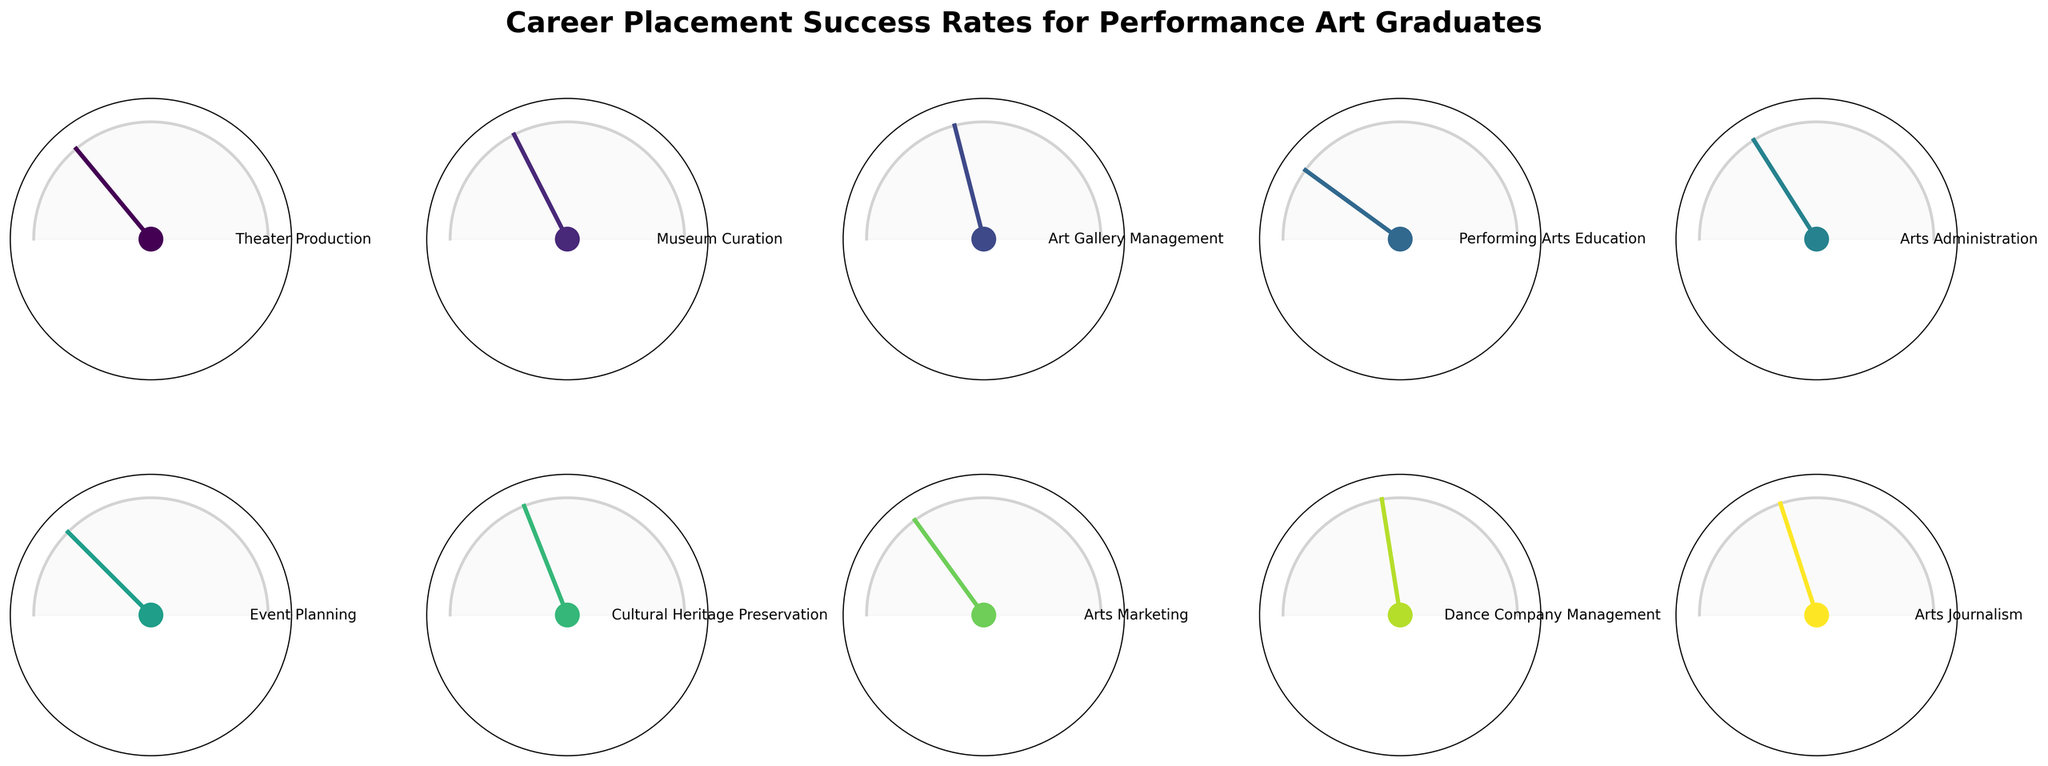What is the highest career placement success rate shown in the figure? The figure represents various career placement success rates, the highest value is identified as "Performing Arts Education" at 80%.
Answer: 80% Which field has the lowest placement success rate? The field with the lowest success rate can be identified as "Dance Company Management" with a rate of 55%.
Answer: Dance Company Management How many fields have a placement success rate of 70% or higher? By visually counting the fields that have placement success rates of 70% or higher, we find "Theater Production" (72%), "Performing Arts Education" (80%), "Event Planning" (75%), and "Arts Marketing" (70%), totaling 4 fields.
Answer: 4 Which fields have placement success rates between 60% and 70%? Fields with placement rates between 60% and 70% are: "Museum Curation" (65%), "Arts Administration" (68%), "Cultural Heritage Preservation" (62%), and "Arts Journalism" (60%).
Answer: Museum Curation, Arts Administration, Cultural Heritage Preservation, Arts Journalism What is the average career placement success rate across all fields? Summing up all placement rates: 72 + 65 + 58 + 80 + 68 + 75 + 62 + 70 + 55 + 60 = 665. There are 10 fields, so the average placement rate is 665 / 10 = 66.5%.
Answer: 66.5% Which fields have a placement rate higher than 72%? By identifying the fields with placement rates above 72%, we find "Performing Arts Education" (80%) and "Event Planning" (75%).
Answer: Performing Arts Education, Event Planning Does the field "Arts Administration" have a higher placement rate than "Arts Marketing"? "Arts Administration" has a placement rate of 68%, while "Arts Marketing" has 70%. Thus, "Arts Administration" has a lower rate than "Arts Marketing".
Answer: No What is the placement rate difference between the highest and lowest fields? The highest rate is "Performing Arts Education" at 80%, and the lowest rate is "Dance Company Management" at 55%. The difference is 80% - 55% = 25%.
Answer: 25% How many fields have placement rates below 60%? Only one field, "Dance Company Management", has a placement rate below 60% at 55%.
Answer: 1 Based on the figure, which two fields have placement rates closest to each other? "Museum Curation" (65%) and "Arts Administration" (68%) have the closest rates, with a difference of 3%.
Answer: Museum Curation, Arts Administration 